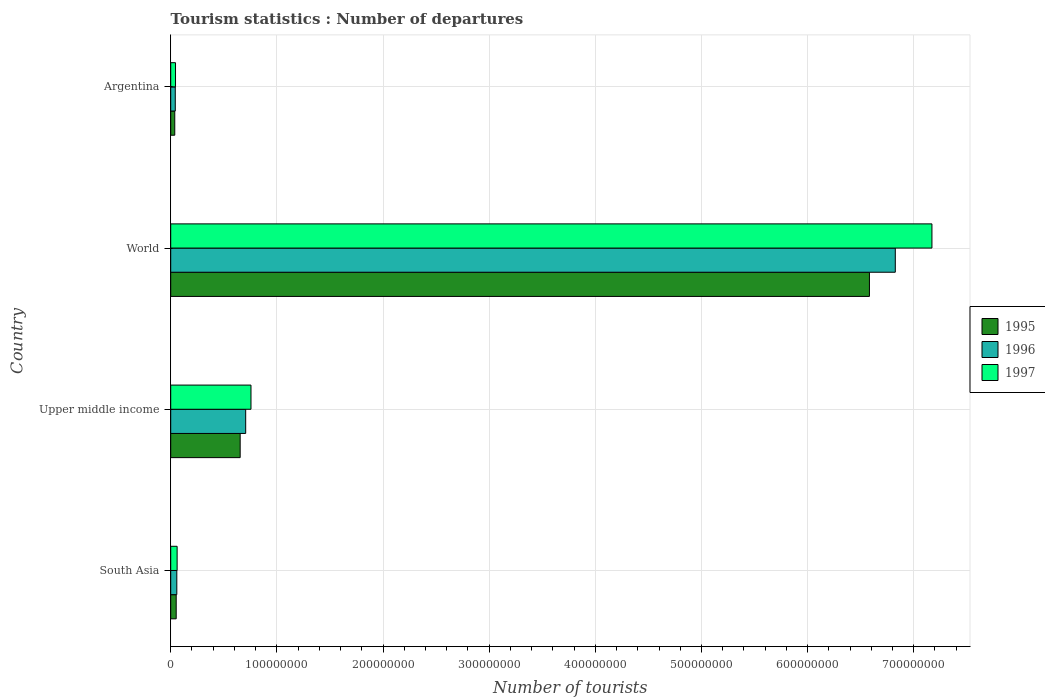Are the number of bars per tick equal to the number of legend labels?
Offer a terse response. Yes. Are the number of bars on each tick of the Y-axis equal?
Make the answer very short. Yes. How many bars are there on the 3rd tick from the top?
Give a very brief answer. 3. In how many cases, is the number of bars for a given country not equal to the number of legend labels?
Offer a terse response. 0. What is the number of tourist departures in 1995 in Argentina?
Your answer should be very brief. 3.82e+06. Across all countries, what is the maximum number of tourist departures in 1996?
Provide a short and direct response. 6.83e+08. Across all countries, what is the minimum number of tourist departures in 1997?
Your answer should be very brief. 4.52e+06. In which country was the number of tourist departures in 1995 minimum?
Provide a succinct answer. Argentina. What is the total number of tourist departures in 1995 in the graph?
Provide a short and direct response. 7.33e+08. What is the difference between the number of tourist departures in 1995 in Argentina and that in South Asia?
Provide a short and direct response. -1.35e+06. What is the difference between the number of tourist departures in 1997 in Argentina and the number of tourist departures in 1995 in South Asia?
Offer a very short reply. -6.49e+05. What is the average number of tourist departures in 1997 per country?
Provide a short and direct response. 2.01e+08. What is the difference between the number of tourist departures in 1996 and number of tourist departures in 1995 in World?
Provide a succinct answer. 2.44e+07. What is the ratio of the number of tourist departures in 1995 in Argentina to that in South Asia?
Provide a short and direct response. 0.74. Is the difference between the number of tourist departures in 1996 in South Asia and Upper middle income greater than the difference between the number of tourist departures in 1995 in South Asia and Upper middle income?
Your response must be concise. No. What is the difference between the highest and the second highest number of tourist departures in 1997?
Offer a very short reply. 6.42e+08. What is the difference between the highest and the lowest number of tourist departures in 1995?
Give a very brief answer. 6.54e+08. In how many countries, is the number of tourist departures in 1997 greater than the average number of tourist departures in 1997 taken over all countries?
Your response must be concise. 1. Is the sum of the number of tourist departures in 1997 in Argentina and Upper middle income greater than the maximum number of tourist departures in 1995 across all countries?
Provide a succinct answer. No. How many bars are there?
Give a very brief answer. 12. Are all the bars in the graph horizontal?
Your response must be concise. Yes. Does the graph contain grids?
Make the answer very short. Yes. How many legend labels are there?
Your answer should be compact. 3. How are the legend labels stacked?
Your answer should be compact. Vertical. What is the title of the graph?
Offer a terse response. Tourism statistics : Number of departures. Does "1994" appear as one of the legend labels in the graph?
Keep it short and to the point. No. What is the label or title of the X-axis?
Ensure brevity in your answer.  Number of tourists. What is the Number of tourists in 1995 in South Asia?
Provide a short and direct response. 5.17e+06. What is the Number of tourists in 1996 in South Asia?
Offer a very short reply. 5.74e+06. What is the Number of tourists of 1997 in South Asia?
Your answer should be compact. 6.04e+06. What is the Number of tourists in 1995 in Upper middle income?
Your response must be concise. 6.54e+07. What is the Number of tourists in 1996 in Upper middle income?
Ensure brevity in your answer.  7.06e+07. What is the Number of tourists in 1997 in Upper middle income?
Make the answer very short. 7.56e+07. What is the Number of tourists of 1995 in World?
Ensure brevity in your answer.  6.58e+08. What is the Number of tourists of 1996 in World?
Provide a succinct answer. 6.83e+08. What is the Number of tourists in 1997 in World?
Provide a short and direct response. 7.17e+08. What is the Number of tourists of 1995 in Argentina?
Make the answer very short. 3.82e+06. What is the Number of tourists of 1996 in Argentina?
Offer a very short reply. 4.30e+06. What is the Number of tourists of 1997 in Argentina?
Offer a terse response. 4.52e+06. Across all countries, what is the maximum Number of tourists of 1995?
Ensure brevity in your answer.  6.58e+08. Across all countries, what is the maximum Number of tourists of 1996?
Make the answer very short. 6.83e+08. Across all countries, what is the maximum Number of tourists of 1997?
Give a very brief answer. 7.17e+08. Across all countries, what is the minimum Number of tourists in 1995?
Offer a terse response. 3.82e+06. Across all countries, what is the minimum Number of tourists in 1996?
Provide a succinct answer. 4.30e+06. Across all countries, what is the minimum Number of tourists in 1997?
Provide a succinct answer. 4.52e+06. What is the total Number of tourists of 1995 in the graph?
Your answer should be very brief. 7.33e+08. What is the total Number of tourists in 1996 in the graph?
Provide a short and direct response. 7.63e+08. What is the total Number of tourists in 1997 in the graph?
Make the answer very short. 8.03e+08. What is the difference between the Number of tourists of 1995 in South Asia and that in Upper middle income?
Ensure brevity in your answer.  -6.03e+07. What is the difference between the Number of tourists of 1996 in South Asia and that in Upper middle income?
Offer a very short reply. -6.49e+07. What is the difference between the Number of tourists of 1997 in South Asia and that in Upper middle income?
Offer a terse response. -6.96e+07. What is the difference between the Number of tourists in 1995 in South Asia and that in World?
Make the answer very short. -6.53e+08. What is the difference between the Number of tourists in 1996 in South Asia and that in World?
Keep it short and to the point. -6.77e+08. What is the difference between the Number of tourists in 1997 in South Asia and that in World?
Offer a terse response. -7.11e+08. What is the difference between the Number of tourists in 1995 in South Asia and that in Argentina?
Offer a very short reply. 1.35e+06. What is the difference between the Number of tourists in 1996 in South Asia and that in Argentina?
Ensure brevity in your answer.  1.44e+06. What is the difference between the Number of tourists of 1997 in South Asia and that in Argentina?
Provide a short and direct response. 1.52e+06. What is the difference between the Number of tourists in 1995 in Upper middle income and that in World?
Make the answer very short. -5.93e+08. What is the difference between the Number of tourists of 1996 in Upper middle income and that in World?
Keep it short and to the point. -6.12e+08. What is the difference between the Number of tourists of 1997 in Upper middle income and that in World?
Provide a short and direct response. -6.42e+08. What is the difference between the Number of tourists in 1995 in Upper middle income and that in Argentina?
Your answer should be compact. 6.16e+07. What is the difference between the Number of tourists in 1996 in Upper middle income and that in Argentina?
Offer a terse response. 6.63e+07. What is the difference between the Number of tourists in 1997 in Upper middle income and that in Argentina?
Make the answer very short. 7.11e+07. What is the difference between the Number of tourists in 1995 in World and that in Argentina?
Offer a very short reply. 6.54e+08. What is the difference between the Number of tourists of 1996 in World and that in Argentina?
Your answer should be very brief. 6.78e+08. What is the difference between the Number of tourists of 1997 in World and that in Argentina?
Offer a terse response. 7.13e+08. What is the difference between the Number of tourists in 1995 in South Asia and the Number of tourists in 1996 in Upper middle income?
Offer a terse response. -6.55e+07. What is the difference between the Number of tourists in 1995 in South Asia and the Number of tourists in 1997 in Upper middle income?
Give a very brief answer. -7.05e+07. What is the difference between the Number of tourists of 1996 in South Asia and the Number of tourists of 1997 in Upper middle income?
Make the answer very short. -6.99e+07. What is the difference between the Number of tourists of 1995 in South Asia and the Number of tourists of 1996 in World?
Provide a succinct answer. -6.77e+08. What is the difference between the Number of tourists of 1995 in South Asia and the Number of tourists of 1997 in World?
Keep it short and to the point. -7.12e+08. What is the difference between the Number of tourists in 1996 in South Asia and the Number of tourists in 1997 in World?
Provide a succinct answer. -7.11e+08. What is the difference between the Number of tourists of 1995 in South Asia and the Number of tourists of 1996 in Argentina?
Your answer should be very brief. 8.70e+05. What is the difference between the Number of tourists of 1995 in South Asia and the Number of tourists of 1997 in Argentina?
Keep it short and to the point. 6.49e+05. What is the difference between the Number of tourists in 1996 in South Asia and the Number of tourists in 1997 in Argentina?
Offer a terse response. 1.22e+06. What is the difference between the Number of tourists of 1995 in Upper middle income and the Number of tourists of 1996 in World?
Keep it short and to the point. -6.17e+08. What is the difference between the Number of tourists in 1995 in Upper middle income and the Number of tourists in 1997 in World?
Ensure brevity in your answer.  -6.52e+08. What is the difference between the Number of tourists in 1996 in Upper middle income and the Number of tourists in 1997 in World?
Keep it short and to the point. -6.46e+08. What is the difference between the Number of tourists in 1995 in Upper middle income and the Number of tourists in 1996 in Argentina?
Keep it short and to the point. 6.11e+07. What is the difference between the Number of tourists of 1995 in Upper middle income and the Number of tourists of 1997 in Argentina?
Your answer should be very brief. 6.09e+07. What is the difference between the Number of tourists in 1996 in Upper middle income and the Number of tourists in 1997 in Argentina?
Offer a very short reply. 6.61e+07. What is the difference between the Number of tourists in 1995 in World and the Number of tourists in 1996 in Argentina?
Ensure brevity in your answer.  6.54e+08. What is the difference between the Number of tourists of 1995 in World and the Number of tourists of 1997 in Argentina?
Your answer should be very brief. 6.54e+08. What is the difference between the Number of tourists in 1996 in World and the Number of tourists in 1997 in Argentina?
Ensure brevity in your answer.  6.78e+08. What is the average Number of tourists in 1995 per country?
Keep it short and to the point. 1.83e+08. What is the average Number of tourists of 1996 per country?
Offer a very short reply. 1.91e+08. What is the average Number of tourists of 1997 per country?
Provide a short and direct response. 2.01e+08. What is the difference between the Number of tourists in 1995 and Number of tourists in 1996 in South Asia?
Keep it short and to the point. -5.69e+05. What is the difference between the Number of tourists of 1995 and Number of tourists of 1997 in South Asia?
Make the answer very short. -8.75e+05. What is the difference between the Number of tourists of 1996 and Number of tourists of 1997 in South Asia?
Make the answer very short. -3.06e+05. What is the difference between the Number of tourists of 1995 and Number of tourists of 1996 in Upper middle income?
Provide a short and direct response. -5.21e+06. What is the difference between the Number of tourists of 1995 and Number of tourists of 1997 in Upper middle income?
Your answer should be compact. -1.02e+07. What is the difference between the Number of tourists of 1996 and Number of tourists of 1997 in Upper middle income?
Provide a succinct answer. -4.99e+06. What is the difference between the Number of tourists in 1995 and Number of tourists in 1996 in World?
Give a very brief answer. -2.44e+07. What is the difference between the Number of tourists in 1995 and Number of tourists in 1997 in World?
Keep it short and to the point. -5.89e+07. What is the difference between the Number of tourists of 1996 and Number of tourists of 1997 in World?
Your answer should be compact. -3.45e+07. What is the difference between the Number of tourists in 1995 and Number of tourists in 1996 in Argentina?
Your response must be concise. -4.81e+05. What is the difference between the Number of tourists of 1995 and Number of tourists of 1997 in Argentina?
Provide a short and direct response. -7.02e+05. What is the difference between the Number of tourists in 1996 and Number of tourists in 1997 in Argentina?
Your response must be concise. -2.21e+05. What is the ratio of the Number of tourists in 1995 in South Asia to that in Upper middle income?
Your answer should be very brief. 0.08. What is the ratio of the Number of tourists of 1996 in South Asia to that in Upper middle income?
Provide a short and direct response. 0.08. What is the ratio of the Number of tourists of 1997 in South Asia to that in Upper middle income?
Keep it short and to the point. 0.08. What is the ratio of the Number of tourists in 1995 in South Asia to that in World?
Your answer should be compact. 0.01. What is the ratio of the Number of tourists of 1996 in South Asia to that in World?
Your response must be concise. 0.01. What is the ratio of the Number of tourists in 1997 in South Asia to that in World?
Give a very brief answer. 0.01. What is the ratio of the Number of tourists of 1995 in South Asia to that in Argentina?
Provide a succinct answer. 1.35. What is the ratio of the Number of tourists in 1996 in South Asia to that in Argentina?
Make the answer very short. 1.33. What is the ratio of the Number of tourists in 1997 in South Asia to that in Argentina?
Offer a very short reply. 1.34. What is the ratio of the Number of tourists in 1995 in Upper middle income to that in World?
Ensure brevity in your answer.  0.1. What is the ratio of the Number of tourists in 1996 in Upper middle income to that in World?
Your response must be concise. 0.1. What is the ratio of the Number of tourists in 1997 in Upper middle income to that in World?
Offer a very short reply. 0.11. What is the ratio of the Number of tourists of 1995 in Upper middle income to that in Argentina?
Ensure brevity in your answer.  17.15. What is the ratio of the Number of tourists in 1996 in Upper middle income to that in Argentina?
Make the answer very short. 16.44. What is the ratio of the Number of tourists of 1997 in Upper middle income to that in Argentina?
Offer a terse response. 16.74. What is the ratio of the Number of tourists in 1995 in World to that in Argentina?
Provide a short and direct response. 172.54. What is the ratio of the Number of tourists in 1996 in World to that in Argentina?
Offer a terse response. 158.9. What is the ratio of the Number of tourists in 1997 in World to that in Argentina?
Ensure brevity in your answer.  158.76. What is the difference between the highest and the second highest Number of tourists in 1995?
Make the answer very short. 5.93e+08. What is the difference between the highest and the second highest Number of tourists of 1996?
Keep it short and to the point. 6.12e+08. What is the difference between the highest and the second highest Number of tourists of 1997?
Keep it short and to the point. 6.42e+08. What is the difference between the highest and the lowest Number of tourists of 1995?
Your answer should be compact. 6.54e+08. What is the difference between the highest and the lowest Number of tourists in 1996?
Provide a succinct answer. 6.78e+08. What is the difference between the highest and the lowest Number of tourists in 1997?
Provide a succinct answer. 7.13e+08. 